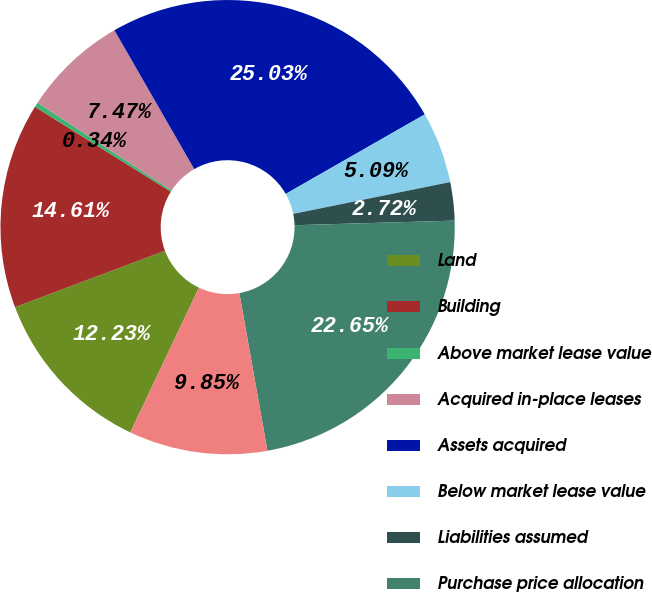Convert chart to OTSL. <chart><loc_0><loc_0><loc_500><loc_500><pie_chart><fcel>Land<fcel>Building<fcel>Above market lease value<fcel>Acquired in-place leases<fcel>Assets acquired<fcel>Below market lease value<fcel>Liabilities assumed<fcel>Purchase price allocation<fcel>Net consideration funded by us<nl><fcel>12.23%<fcel>14.61%<fcel>0.34%<fcel>7.47%<fcel>25.03%<fcel>5.09%<fcel>2.72%<fcel>22.65%<fcel>9.85%<nl></chart> 